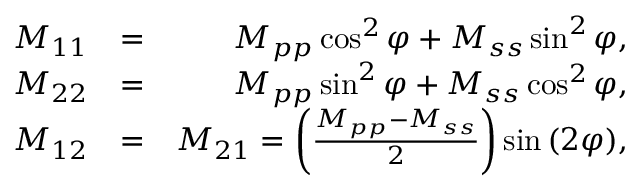Convert formula to latex. <formula><loc_0><loc_0><loc_500><loc_500>\begin{array} { r l r } { M _ { 1 1 } } & { = } & { M _ { p p } \cos ^ { 2 } \varphi + M _ { s s } \sin ^ { 2 } \varphi , } \\ { M _ { 2 2 } } & { = } & { M _ { p p } \sin ^ { 2 } \varphi + M _ { s s } \cos ^ { 2 } \varphi , } \\ { M _ { 1 2 } } & { = } & { M _ { 2 1 } = \left ( \frac { M _ { p p } - M _ { s s } } { 2 } \right ) \sin { ( 2 \varphi ) } , } \end{array}</formula> 